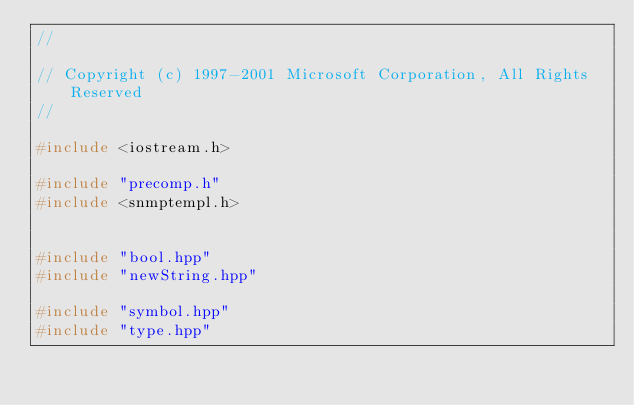<code> <loc_0><loc_0><loc_500><loc_500><_C++_>//

// Copyright (c) 1997-2001 Microsoft Corporation, All Rights Reserved
//

#include <iostream.h>

#include "precomp.h"
#include <snmptempl.h>


#include "bool.hpp"
#include "newString.hpp"

#include "symbol.hpp"
#include "type.hpp"</code> 